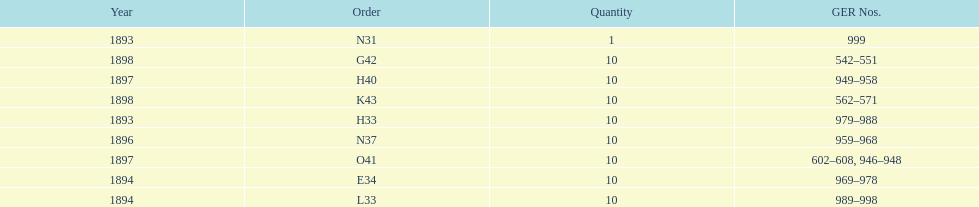Were there more n31 or e34 ordered? E34. 